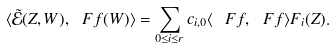<formula> <loc_0><loc_0><loc_500><loc_500>\langle \tilde { \mathcal { E } } ( Z , W ) , \ F f ( W ) \rangle = \sum _ { 0 \leq i \leq r } c _ { i , 0 } \langle \ F f , \ F f \rangle F _ { i } ( Z ) .</formula> 